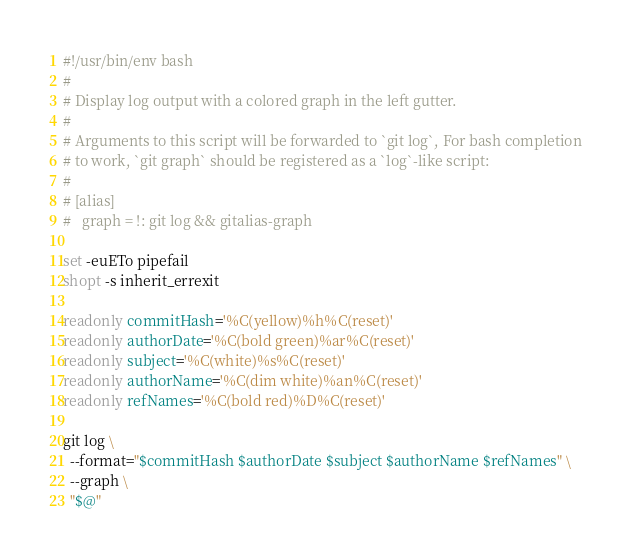<code> <loc_0><loc_0><loc_500><loc_500><_Bash_>#!/usr/bin/env bash
#
# Display log output with a colored graph in the left gutter.
#
# Arguments to this script will be forwarded to `git log`, For bash completion
# to work, `git graph` should be registered as a `log`-like script:
#
# [alias]
# 	graph = !: git log && gitalias-graph

set -euETo pipefail
shopt -s inherit_errexit

readonly commitHash='%C(yellow)%h%C(reset)'
readonly authorDate='%C(bold green)%ar%C(reset)'
readonly subject='%C(white)%s%C(reset)'
readonly authorName='%C(dim white)%an%C(reset)'
readonly refNames='%C(bold red)%D%C(reset)'

git log \
  --format="$commitHash $authorDate $subject $authorName $refNames" \
  --graph \
  "$@"
</code> 